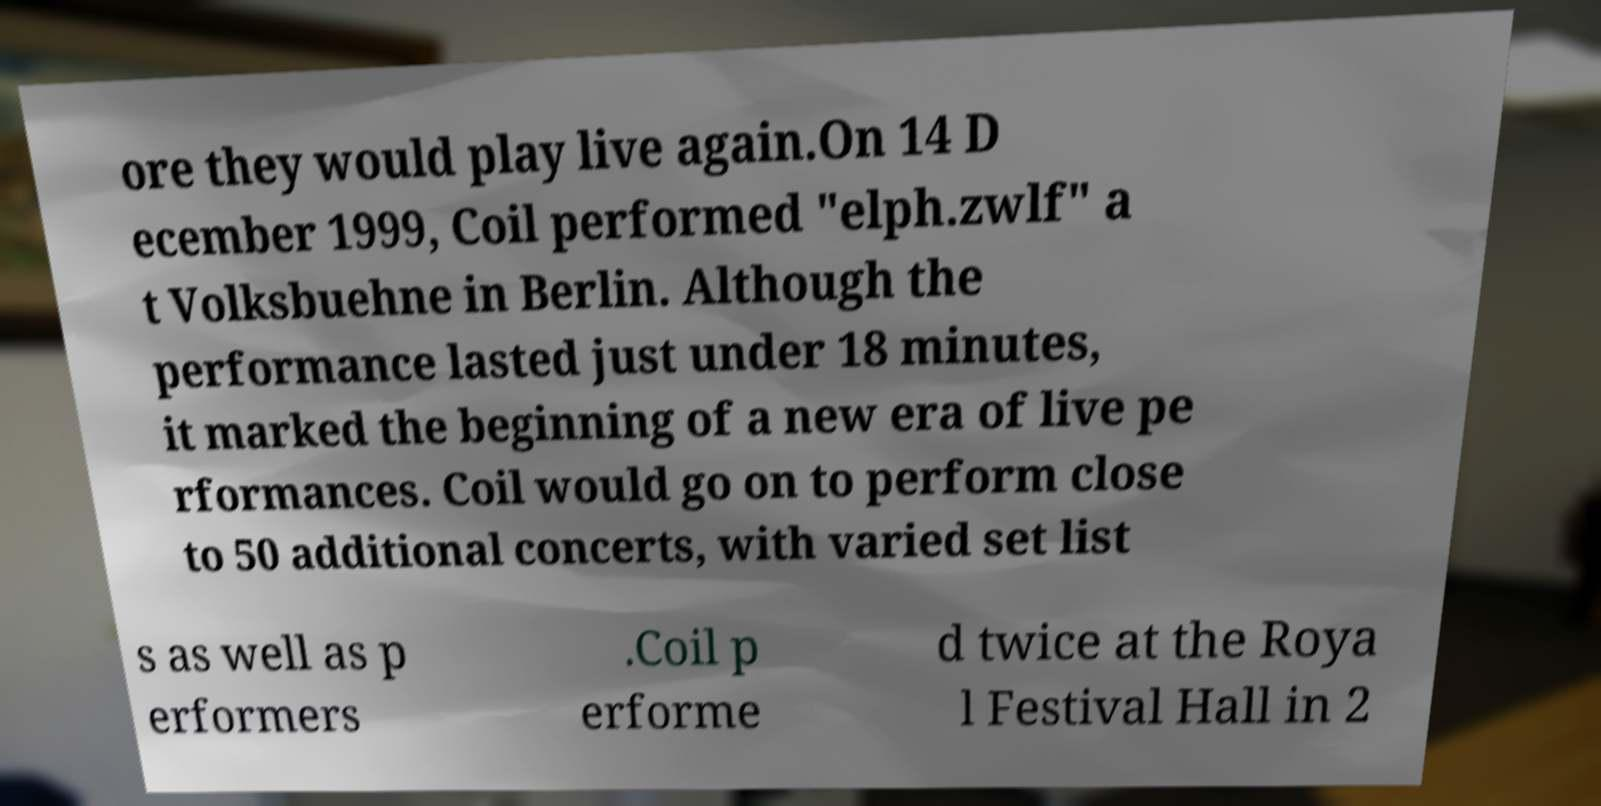I need the written content from this picture converted into text. Can you do that? ore they would play live again.On 14 D ecember 1999, Coil performed "elph.zwlf" a t Volksbuehne in Berlin. Although the performance lasted just under 18 minutes, it marked the beginning of a new era of live pe rformances. Coil would go on to perform close to 50 additional concerts, with varied set list s as well as p erformers .Coil p erforme d twice at the Roya l Festival Hall in 2 